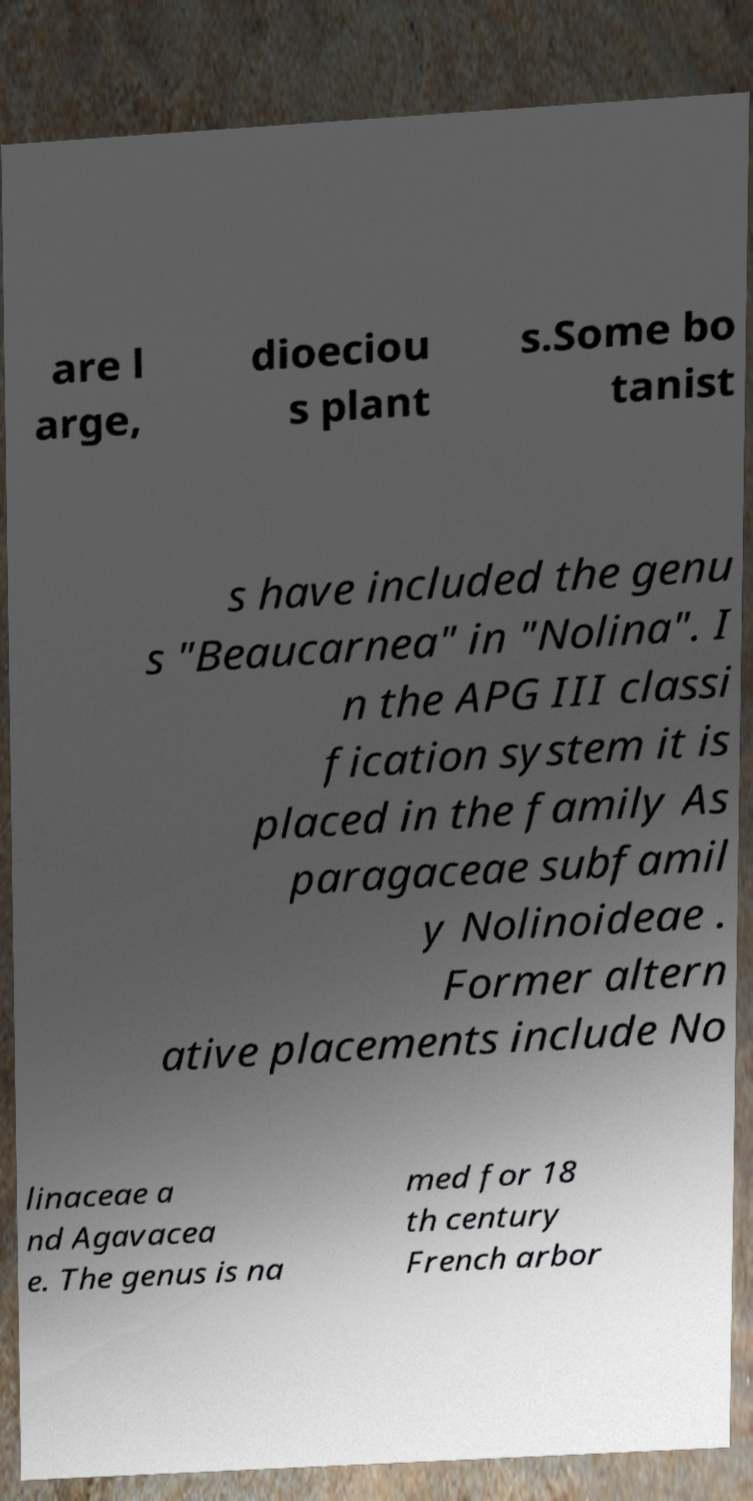For documentation purposes, I need the text within this image transcribed. Could you provide that? are l arge, dioeciou s plant s.Some bo tanist s have included the genu s "Beaucarnea" in "Nolina". I n the APG III classi fication system it is placed in the family As paragaceae subfamil y Nolinoideae . Former altern ative placements include No linaceae a nd Agavacea e. The genus is na med for 18 th century French arbor 